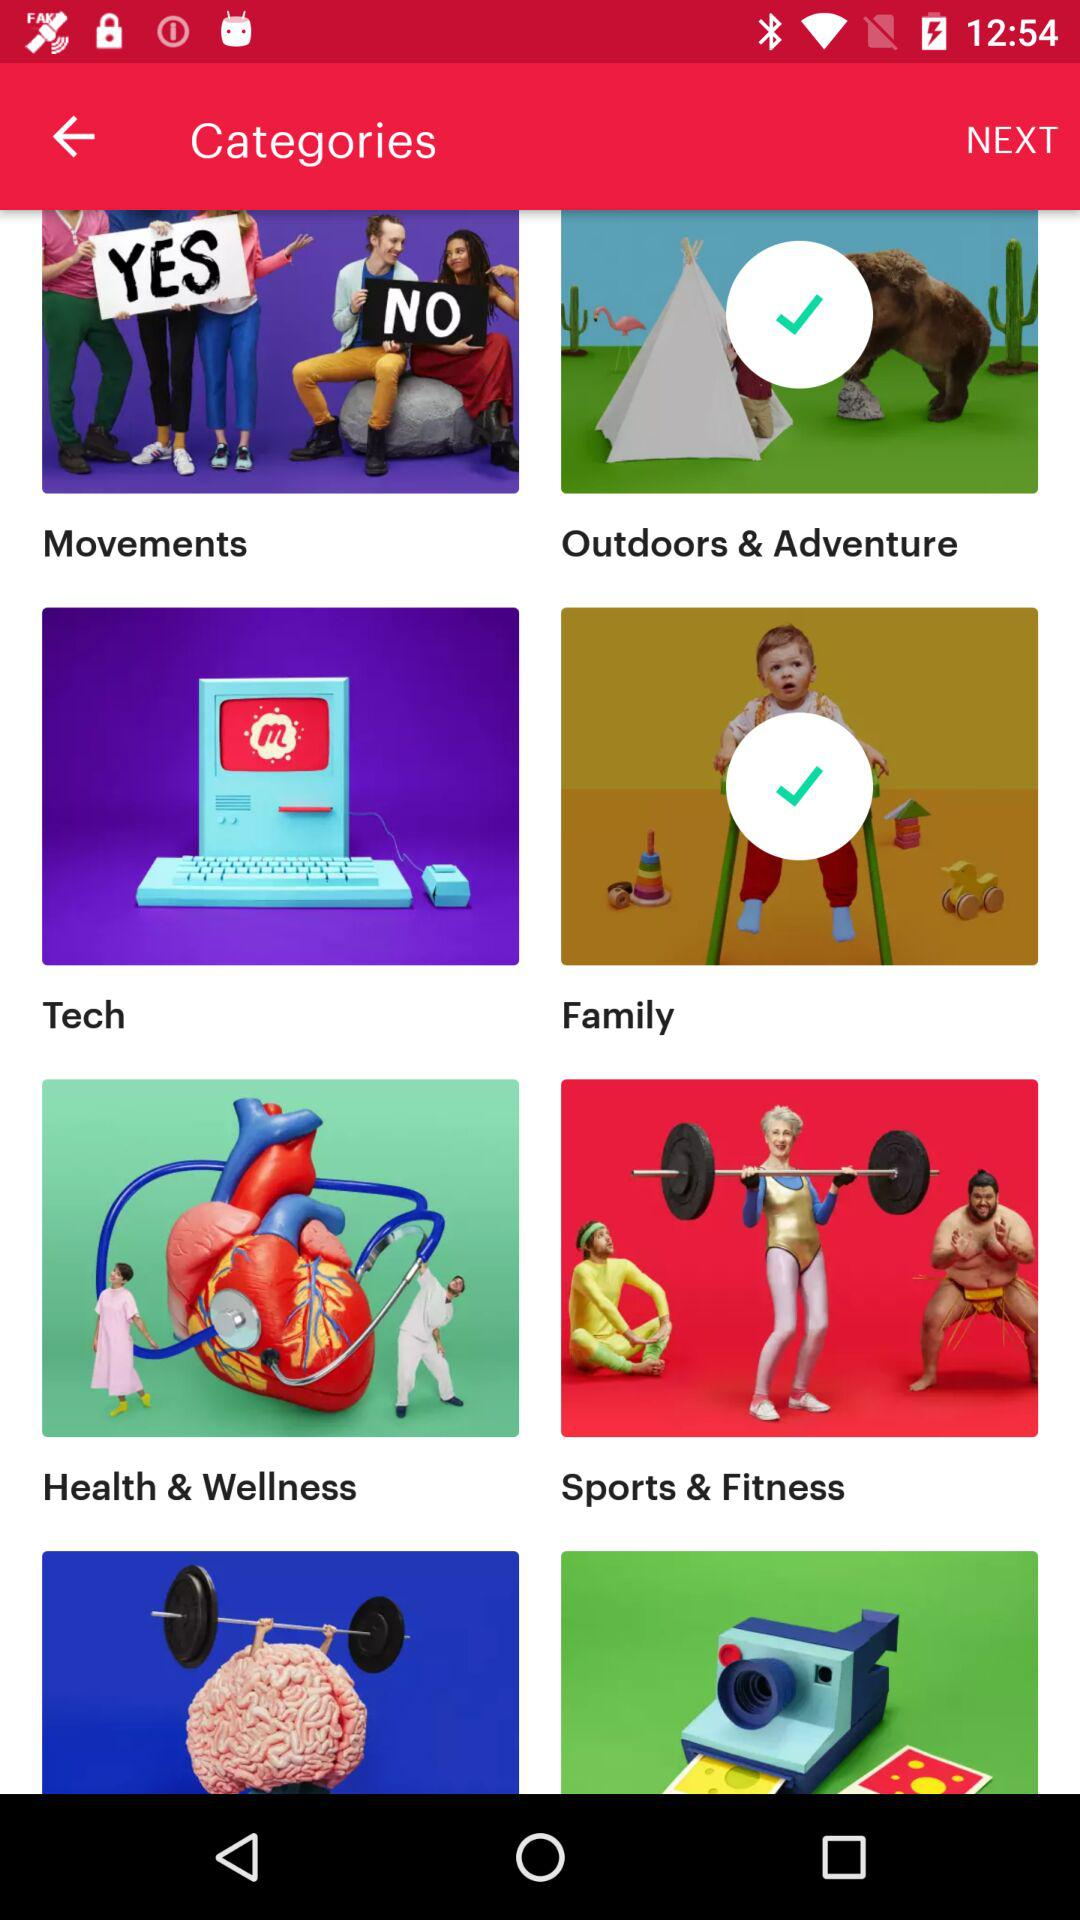How many items have a check mark?
Answer the question using a single word or phrase. 2 